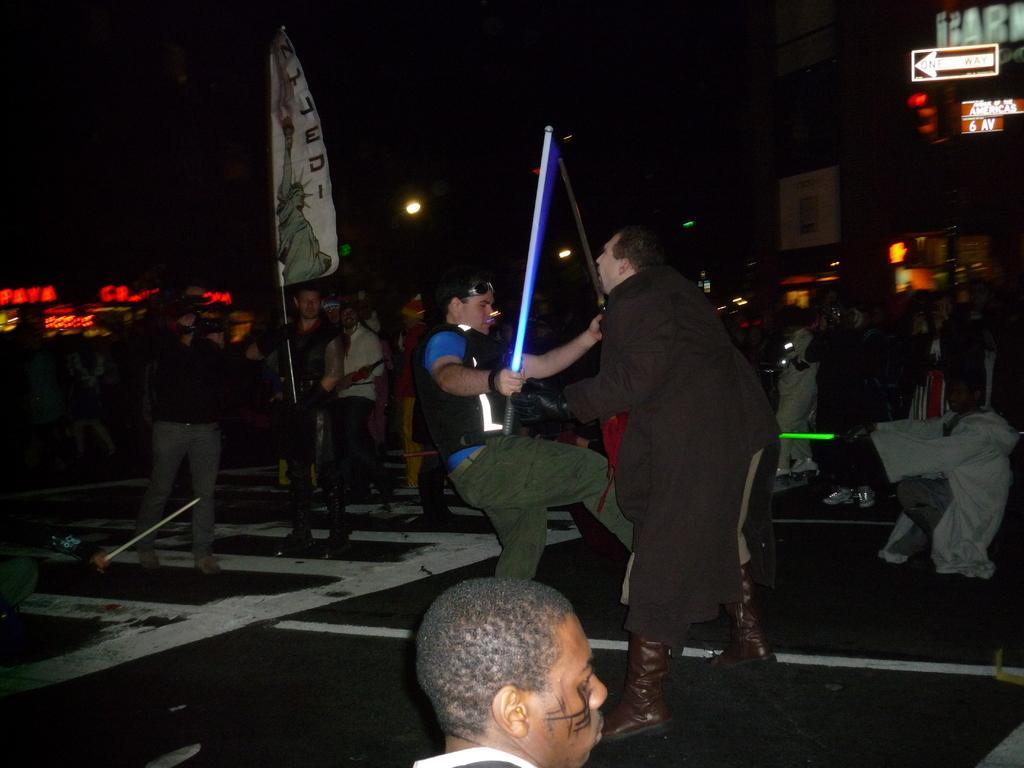Can you describe this image briefly? Here we can see group of people and he is holding a flag with his hand. There are boards, lights, and a building. There is a dark background. 